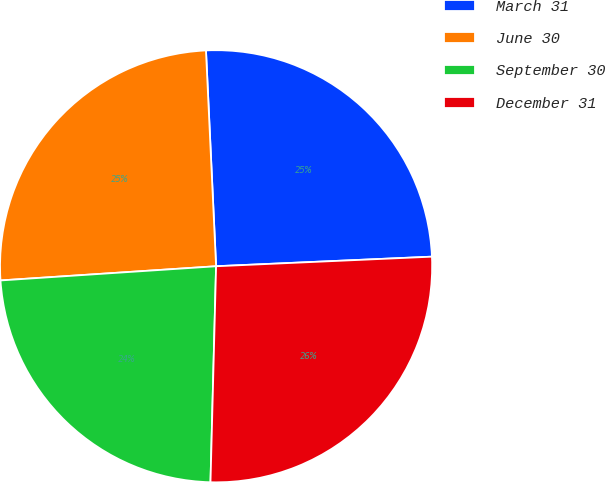Convert chart. <chart><loc_0><loc_0><loc_500><loc_500><pie_chart><fcel>March 31<fcel>June 30<fcel>September 30<fcel>December 31<nl><fcel>25.04%<fcel>25.3%<fcel>23.54%<fcel>26.12%<nl></chart> 